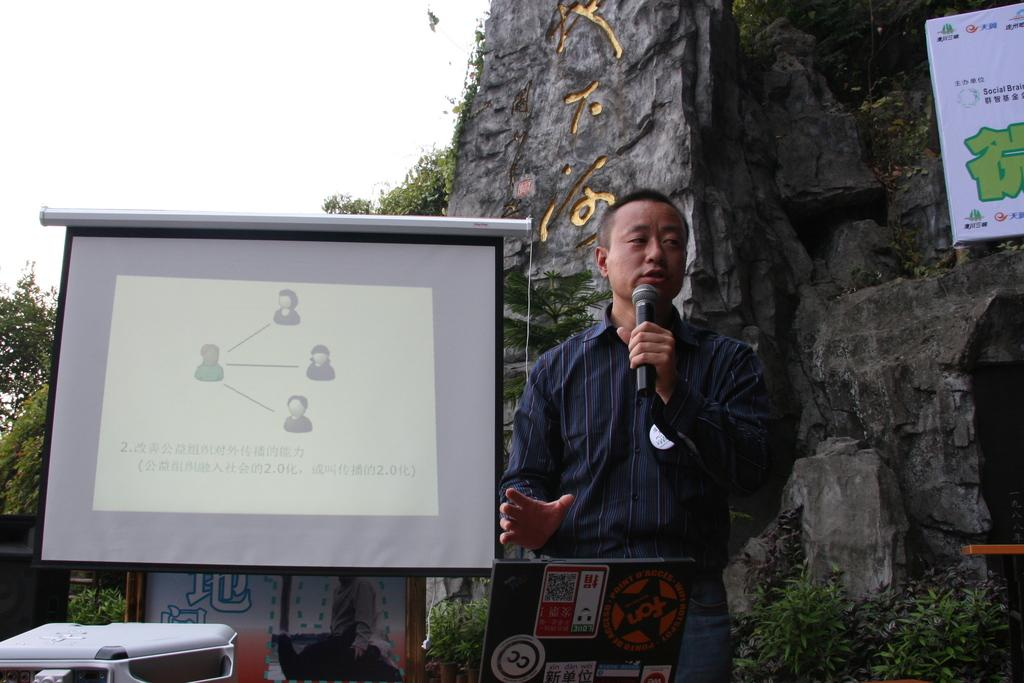What is the main object in the image? There is a screen in the image. What else can be seen on the screen? A man is holding a microphone in the image. What other items are present in the image? There is a poster, a banner, trees, plants, and the sky is visible at the top of the image. What type of fruit is hanging from the banner in the image? There is no fruit present in the image, and therefore no such activity can be observed. 